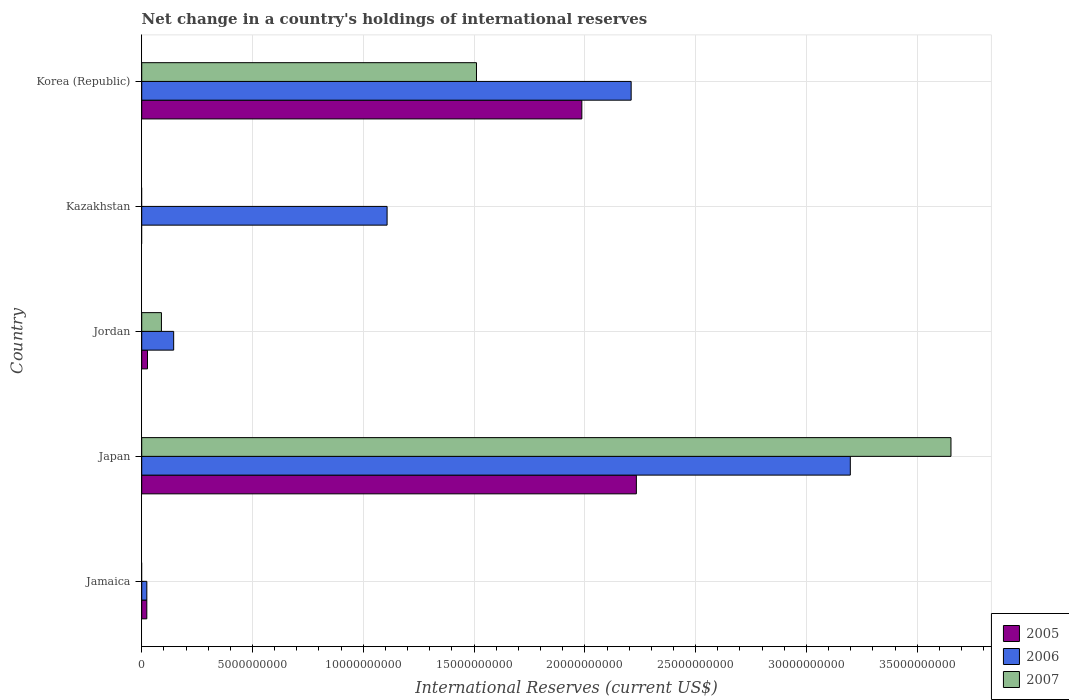Are the number of bars on each tick of the Y-axis equal?
Your answer should be compact. No. How many bars are there on the 2nd tick from the top?
Ensure brevity in your answer.  1. What is the label of the 3rd group of bars from the top?
Offer a terse response. Jordan. What is the international reserves in 2005 in Jamaica?
Provide a succinct answer. 2.30e+08. Across all countries, what is the maximum international reserves in 2007?
Offer a terse response. 3.65e+1. Across all countries, what is the minimum international reserves in 2006?
Offer a very short reply. 2.30e+08. In which country was the international reserves in 2007 maximum?
Your answer should be compact. Japan. What is the total international reserves in 2007 in the graph?
Provide a succinct answer. 5.25e+1. What is the difference between the international reserves in 2006 in Jamaica and that in Kazakhstan?
Give a very brief answer. -1.08e+1. What is the difference between the international reserves in 2005 in Japan and the international reserves in 2006 in Korea (Republic)?
Keep it short and to the point. 2.35e+08. What is the average international reserves in 2007 per country?
Provide a short and direct response. 1.05e+1. What is the difference between the international reserves in 2007 and international reserves in 2005 in Jordan?
Ensure brevity in your answer.  6.29e+08. What is the ratio of the international reserves in 2005 in Jamaica to that in Jordan?
Give a very brief answer. 0.88. What is the difference between the highest and the second highest international reserves in 2006?
Give a very brief answer. 9.89e+09. What is the difference between the highest and the lowest international reserves in 2007?
Provide a succinct answer. 3.65e+1. Is the sum of the international reserves in 2007 in Jordan and Korea (Republic) greater than the maximum international reserves in 2006 across all countries?
Make the answer very short. No. Are all the bars in the graph horizontal?
Your answer should be compact. Yes. What is the difference between two consecutive major ticks on the X-axis?
Make the answer very short. 5.00e+09. Are the values on the major ticks of X-axis written in scientific E-notation?
Keep it short and to the point. No. Does the graph contain grids?
Provide a succinct answer. Yes. Where does the legend appear in the graph?
Provide a succinct answer. Bottom right. How many legend labels are there?
Offer a very short reply. 3. What is the title of the graph?
Offer a terse response. Net change in a country's holdings of international reserves. What is the label or title of the X-axis?
Offer a very short reply. International Reserves (current US$). What is the International Reserves (current US$) of 2005 in Jamaica?
Your response must be concise. 2.30e+08. What is the International Reserves (current US$) of 2006 in Jamaica?
Your answer should be compact. 2.30e+08. What is the International Reserves (current US$) of 2007 in Jamaica?
Give a very brief answer. 0. What is the International Reserves (current US$) of 2005 in Japan?
Give a very brief answer. 2.23e+1. What is the International Reserves (current US$) of 2006 in Japan?
Your response must be concise. 3.20e+1. What is the International Reserves (current US$) of 2007 in Japan?
Keep it short and to the point. 3.65e+1. What is the International Reserves (current US$) in 2005 in Jordan?
Your answer should be very brief. 2.61e+08. What is the International Reserves (current US$) of 2006 in Jordan?
Keep it short and to the point. 1.44e+09. What is the International Reserves (current US$) in 2007 in Jordan?
Ensure brevity in your answer.  8.90e+08. What is the International Reserves (current US$) of 2005 in Kazakhstan?
Provide a short and direct response. 0. What is the International Reserves (current US$) in 2006 in Kazakhstan?
Offer a terse response. 1.11e+1. What is the International Reserves (current US$) in 2007 in Kazakhstan?
Provide a short and direct response. 0. What is the International Reserves (current US$) in 2005 in Korea (Republic)?
Give a very brief answer. 1.99e+1. What is the International Reserves (current US$) of 2006 in Korea (Republic)?
Keep it short and to the point. 2.21e+1. What is the International Reserves (current US$) of 2007 in Korea (Republic)?
Your response must be concise. 1.51e+1. Across all countries, what is the maximum International Reserves (current US$) of 2005?
Your answer should be very brief. 2.23e+1. Across all countries, what is the maximum International Reserves (current US$) of 2006?
Your answer should be very brief. 3.20e+1. Across all countries, what is the maximum International Reserves (current US$) in 2007?
Provide a succinct answer. 3.65e+1. Across all countries, what is the minimum International Reserves (current US$) of 2005?
Your response must be concise. 0. Across all countries, what is the minimum International Reserves (current US$) of 2006?
Your answer should be very brief. 2.30e+08. Across all countries, what is the minimum International Reserves (current US$) in 2007?
Your response must be concise. 0. What is the total International Reserves (current US$) in 2005 in the graph?
Offer a terse response. 4.27e+1. What is the total International Reserves (current US$) of 2006 in the graph?
Provide a short and direct response. 6.68e+1. What is the total International Reserves (current US$) in 2007 in the graph?
Offer a very short reply. 5.25e+1. What is the difference between the International Reserves (current US$) in 2005 in Jamaica and that in Japan?
Offer a very short reply. -2.21e+1. What is the difference between the International Reserves (current US$) in 2006 in Jamaica and that in Japan?
Ensure brevity in your answer.  -3.18e+1. What is the difference between the International Reserves (current US$) in 2005 in Jamaica and that in Jordan?
Give a very brief answer. -3.08e+07. What is the difference between the International Reserves (current US$) of 2006 in Jamaica and that in Jordan?
Provide a short and direct response. -1.21e+09. What is the difference between the International Reserves (current US$) of 2006 in Jamaica and that in Kazakhstan?
Keep it short and to the point. -1.08e+1. What is the difference between the International Reserves (current US$) of 2005 in Jamaica and that in Korea (Republic)?
Give a very brief answer. -1.96e+1. What is the difference between the International Reserves (current US$) of 2006 in Jamaica and that in Korea (Republic)?
Ensure brevity in your answer.  -2.19e+1. What is the difference between the International Reserves (current US$) of 2005 in Japan and that in Jordan?
Provide a short and direct response. 2.21e+1. What is the difference between the International Reserves (current US$) in 2006 in Japan and that in Jordan?
Offer a very short reply. 3.05e+1. What is the difference between the International Reserves (current US$) in 2007 in Japan and that in Jordan?
Your response must be concise. 3.56e+1. What is the difference between the International Reserves (current US$) in 2006 in Japan and that in Kazakhstan?
Offer a very short reply. 2.09e+1. What is the difference between the International Reserves (current US$) of 2005 in Japan and that in Korea (Republic)?
Offer a very short reply. 2.46e+09. What is the difference between the International Reserves (current US$) in 2006 in Japan and that in Korea (Republic)?
Give a very brief answer. 9.89e+09. What is the difference between the International Reserves (current US$) in 2007 in Japan and that in Korea (Republic)?
Give a very brief answer. 2.14e+1. What is the difference between the International Reserves (current US$) in 2006 in Jordan and that in Kazakhstan?
Your answer should be very brief. -9.63e+09. What is the difference between the International Reserves (current US$) of 2005 in Jordan and that in Korea (Republic)?
Offer a very short reply. -1.96e+1. What is the difference between the International Reserves (current US$) in 2006 in Jordan and that in Korea (Republic)?
Provide a short and direct response. -2.06e+1. What is the difference between the International Reserves (current US$) in 2007 in Jordan and that in Korea (Republic)?
Ensure brevity in your answer.  -1.42e+1. What is the difference between the International Reserves (current US$) in 2006 in Kazakhstan and that in Korea (Republic)?
Make the answer very short. -1.10e+1. What is the difference between the International Reserves (current US$) in 2005 in Jamaica and the International Reserves (current US$) in 2006 in Japan?
Your response must be concise. -3.18e+1. What is the difference between the International Reserves (current US$) in 2005 in Jamaica and the International Reserves (current US$) in 2007 in Japan?
Provide a succinct answer. -3.63e+1. What is the difference between the International Reserves (current US$) in 2006 in Jamaica and the International Reserves (current US$) in 2007 in Japan?
Make the answer very short. -3.63e+1. What is the difference between the International Reserves (current US$) in 2005 in Jamaica and the International Reserves (current US$) in 2006 in Jordan?
Your answer should be very brief. -1.21e+09. What is the difference between the International Reserves (current US$) in 2005 in Jamaica and the International Reserves (current US$) in 2007 in Jordan?
Give a very brief answer. -6.60e+08. What is the difference between the International Reserves (current US$) of 2006 in Jamaica and the International Reserves (current US$) of 2007 in Jordan?
Make the answer very short. -6.60e+08. What is the difference between the International Reserves (current US$) of 2005 in Jamaica and the International Reserves (current US$) of 2006 in Kazakhstan?
Give a very brief answer. -1.08e+1. What is the difference between the International Reserves (current US$) of 2005 in Jamaica and the International Reserves (current US$) of 2006 in Korea (Republic)?
Offer a terse response. -2.19e+1. What is the difference between the International Reserves (current US$) in 2005 in Jamaica and the International Reserves (current US$) in 2007 in Korea (Republic)?
Your answer should be compact. -1.49e+1. What is the difference between the International Reserves (current US$) of 2006 in Jamaica and the International Reserves (current US$) of 2007 in Korea (Republic)?
Your answer should be very brief. -1.49e+1. What is the difference between the International Reserves (current US$) in 2005 in Japan and the International Reserves (current US$) in 2006 in Jordan?
Offer a very short reply. 2.09e+1. What is the difference between the International Reserves (current US$) in 2005 in Japan and the International Reserves (current US$) in 2007 in Jordan?
Keep it short and to the point. 2.14e+1. What is the difference between the International Reserves (current US$) in 2006 in Japan and the International Reserves (current US$) in 2007 in Jordan?
Offer a very short reply. 3.11e+1. What is the difference between the International Reserves (current US$) of 2005 in Japan and the International Reserves (current US$) of 2006 in Kazakhstan?
Offer a terse response. 1.13e+1. What is the difference between the International Reserves (current US$) of 2005 in Japan and the International Reserves (current US$) of 2006 in Korea (Republic)?
Provide a succinct answer. 2.35e+08. What is the difference between the International Reserves (current US$) of 2005 in Japan and the International Reserves (current US$) of 2007 in Korea (Republic)?
Make the answer very short. 7.22e+09. What is the difference between the International Reserves (current US$) in 2006 in Japan and the International Reserves (current US$) in 2007 in Korea (Republic)?
Give a very brief answer. 1.69e+1. What is the difference between the International Reserves (current US$) in 2005 in Jordan and the International Reserves (current US$) in 2006 in Kazakhstan?
Offer a terse response. -1.08e+1. What is the difference between the International Reserves (current US$) of 2005 in Jordan and the International Reserves (current US$) of 2006 in Korea (Republic)?
Offer a terse response. -2.18e+1. What is the difference between the International Reserves (current US$) in 2005 in Jordan and the International Reserves (current US$) in 2007 in Korea (Republic)?
Your response must be concise. -1.48e+1. What is the difference between the International Reserves (current US$) of 2006 in Jordan and the International Reserves (current US$) of 2007 in Korea (Republic)?
Ensure brevity in your answer.  -1.37e+1. What is the difference between the International Reserves (current US$) of 2006 in Kazakhstan and the International Reserves (current US$) of 2007 in Korea (Republic)?
Offer a terse response. -4.03e+09. What is the average International Reserves (current US$) of 2005 per country?
Keep it short and to the point. 8.54e+09. What is the average International Reserves (current US$) of 2006 per country?
Your answer should be very brief. 1.34e+1. What is the average International Reserves (current US$) of 2007 per country?
Make the answer very short. 1.05e+1. What is the difference between the International Reserves (current US$) of 2005 and International Reserves (current US$) of 2006 in Jamaica?
Keep it short and to the point. -4.15e+05. What is the difference between the International Reserves (current US$) of 2005 and International Reserves (current US$) of 2006 in Japan?
Your answer should be compact. -9.66e+09. What is the difference between the International Reserves (current US$) of 2005 and International Reserves (current US$) of 2007 in Japan?
Make the answer very short. -1.42e+1. What is the difference between the International Reserves (current US$) of 2006 and International Reserves (current US$) of 2007 in Japan?
Your response must be concise. -4.54e+09. What is the difference between the International Reserves (current US$) of 2005 and International Reserves (current US$) of 2006 in Jordan?
Your answer should be very brief. -1.18e+09. What is the difference between the International Reserves (current US$) in 2005 and International Reserves (current US$) in 2007 in Jordan?
Make the answer very short. -6.29e+08. What is the difference between the International Reserves (current US$) of 2006 and International Reserves (current US$) of 2007 in Jordan?
Your answer should be compact. 5.52e+08. What is the difference between the International Reserves (current US$) of 2005 and International Reserves (current US$) of 2006 in Korea (Republic)?
Offer a terse response. -2.23e+09. What is the difference between the International Reserves (current US$) of 2005 and International Reserves (current US$) of 2007 in Korea (Republic)?
Provide a succinct answer. 4.75e+09. What is the difference between the International Reserves (current US$) of 2006 and International Reserves (current US$) of 2007 in Korea (Republic)?
Offer a very short reply. 6.98e+09. What is the ratio of the International Reserves (current US$) in 2005 in Jamaica to that in Japan?
Your answer should be compact. 0.01. What is the ratio of the International Reserves (current US$) in 2006 in Jamaica to that in Japan?
Keep it short and to the point. 0.01. What is the ratio of the International Reserves (current US$) in 2005 in Jamaica to that in Jordan?
Your answer should be compact. 0.88. What is the ratio of the International Reserves (current US$) of 2006 in Jamaica to that in Jordan?
Offer a terse response. 0.16. What is the ratio of the International Reserves (current US$) of 2006 in Jamaica to that in Kazakhstan?
Your answer should be very brief. 0.02. What is the ratio of the International Reserves (current US$) of 2005 in Jamaica to that in Korea (Republic)?
Your answer should be compact. 0.01. What is the ratio of the International Reserves (current US$) in 2006 in Jamaica to that in Korea (Republic)?
Provide a succinct answer. 0.01. What is the ratio of the International Reserves (current US$) in 2005 in Japan to that in Jordan?
Offer a terse response. 85.62. What is the ratio of the International Reserves (current US$) in 2006 in Japan to that in Jordan?
Ensure brevity in your answer.  22.18. What is the ratio of the International Reserves (current US$) of 2007 in Japan to that in Jordan?
Give a very brief answer. 41.04. What is the ratio of the International Reserves (current US$) in 2006 in Japan to that in Kazakhstan?
Ensure brevity in your answer.  2.89. What is the ratio of the International Reserves (current US$) in 2005 in Japan to that in Korea (Republic)?
Your answer should be compact. 1.12. What is the ratio of the International Reserves (current US$) of 2006 in Japan to that in Korea (Republic)?
Your response must be concise. 1.45. What is the ratio of the International Reserves (current US$) in 2007 in Japan to that in Korea (Republic)?
Make the answer very short. 2.42. What is the ratio of the International Reserves (current US$) of 2006 in Jordan to that in Kazakhstan?
Provide a short and direct response. 0.13. What is the ratio of the International Reserves (current US$) in 2005 in Jordan to that in Korea (Republic)?
Give a very brief answer. 0.01. What is the ratio of the International Reserves (current US$) of 2006 in Jordan to that in Korea (Republic)?
Your answer should be compact. 0.07. What is the ratio of the International Reserves (current US$) in 2007 in Jordan to that in Korea (Republic)?
Offer a very short reply. 0.06. What is the ratio of the International Reserves (current US$) in 2006 in Kazakhstan to that in Korea (Republic)?
Ensure brevity in your answer.  0.5. What is the difference between the highest and the second highest International Reserves (current US$) of 2005?
Your answer should be compact. 2.46e+09. What is the difference between the highest and the second highest International Reserves (current US$) of 2006?
Your answer should be very brief. 9.89e+09. What is the difference between the highest and the second highest International Reserves (current US$) in 2007?
Make the answer very short. 2.14e+1. What is the difference between the highest and the lowest International Reserves (current US$) in 2005?
Offer a terse response. 2.23e+1. What is the difference between the highest and the lowest International Reserves (current US$) in 2006?
Provide a short and direct response. 3.18e+1. What is the difference between the highest and the lowest International Reserves (current US$) of 2007?
Provide a succinct answer. 3.65e+1. 